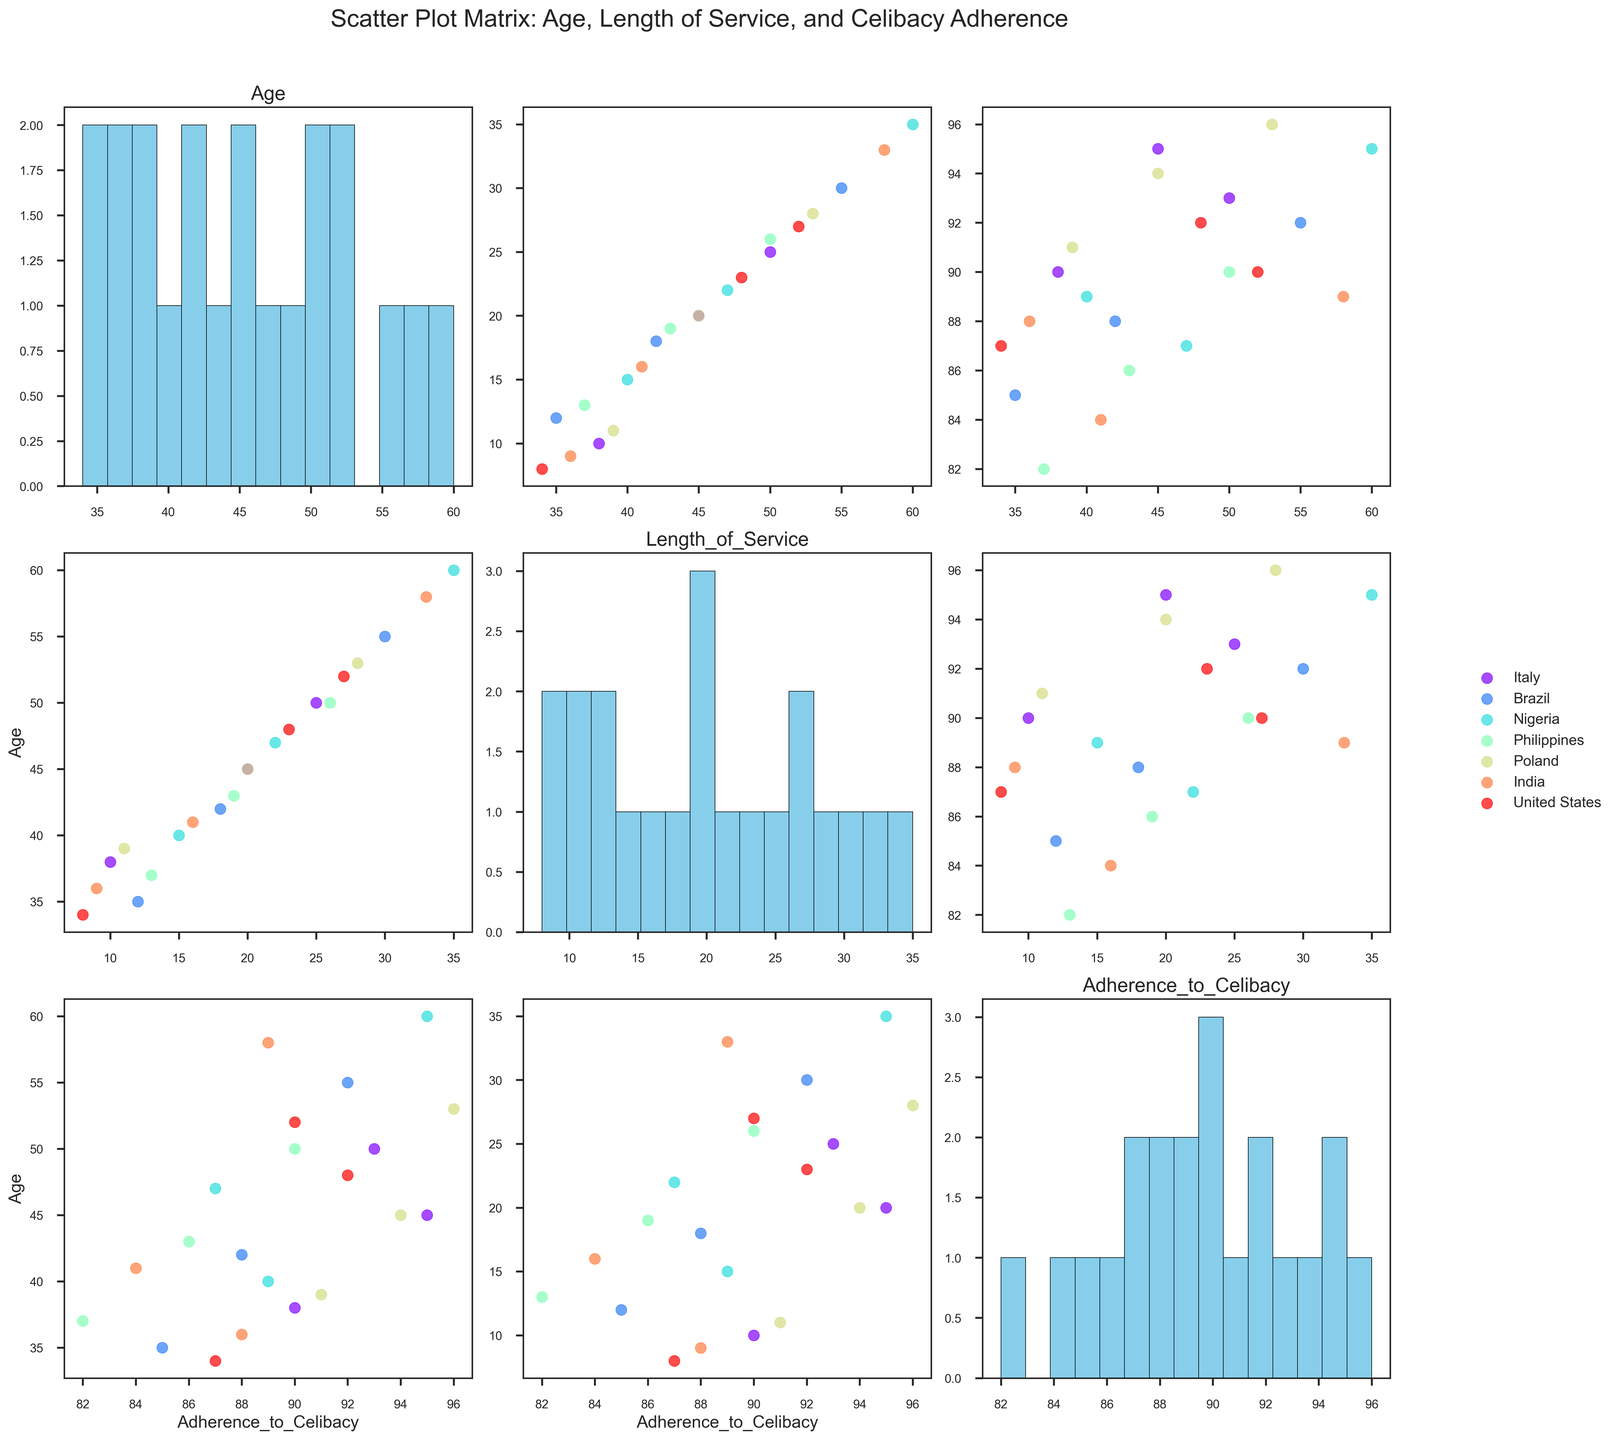What is the title of the figure? The title is located at the top of the figure, generally centered, and written in a larger font than the other text in the figure.
Answer: Scatter Plot Matrix: Age, Length of Service, and Celibacy Adherence How many countries are represented in the scatter plot matrix? To determine the number of countries, we look at the legend on the right side of the figure where each country is listed with its corresponding color.
Answer: 7 Which country has the widest range of ages among priests? Examine the histograms in the diagonal for the "Age" subplots. Identify the histogram that covers the most extensive range on the X-axis.
Answer: Nigeria In the scatter plot comparing Age and Length of Service, which country has the highest adherence to celibacy? Find the highest point in the scatter plot where Age is on one axis and Length of Service is on the other. Refer to the color corresponding to the highest adherence to celibacy in this range.
Answer: Italy On average, do older priests have a higher adherence to celibacy, or do younger priests? Compare the scatter plots of Age vs. Adherence to Celibacy and Length of Service vs. Adherence to Celibacy. Observe the trend lines or clustering of data points to determine the relationship.
Answer: Older priests What is the relationship between Length of Service and Adherence to Celibacy across all countries? Look for trends (positive or negative) in the scatter plots comparing Length of Service to Adherence to Celibacy.
Answer: Positive correlation Which country shows the highest consistency in celibacy adherence among priests with different ages and lengths of service? Identify the country with the most tightly clustered data points in the scatter plots involving Adherence to Celibacy with Age and Length of Service.
Answer: Poland Is there any evident outlier in the celibacy adherence scatter plot for the Philippines? Look at the scatter plot involving Adherence to Celibacy for the Philippines and identify any point significantly deviating from the clustering of other points.
Answer: Yes What might be a possible explanation for any country-specific outliers observed in the scatter plot matrix? Countries with outliers might have specific cultural or societal factors affecting adherence to celibacy. This could require a deeper dive into each country's practices and challenges.
Answer: Cultural factors 